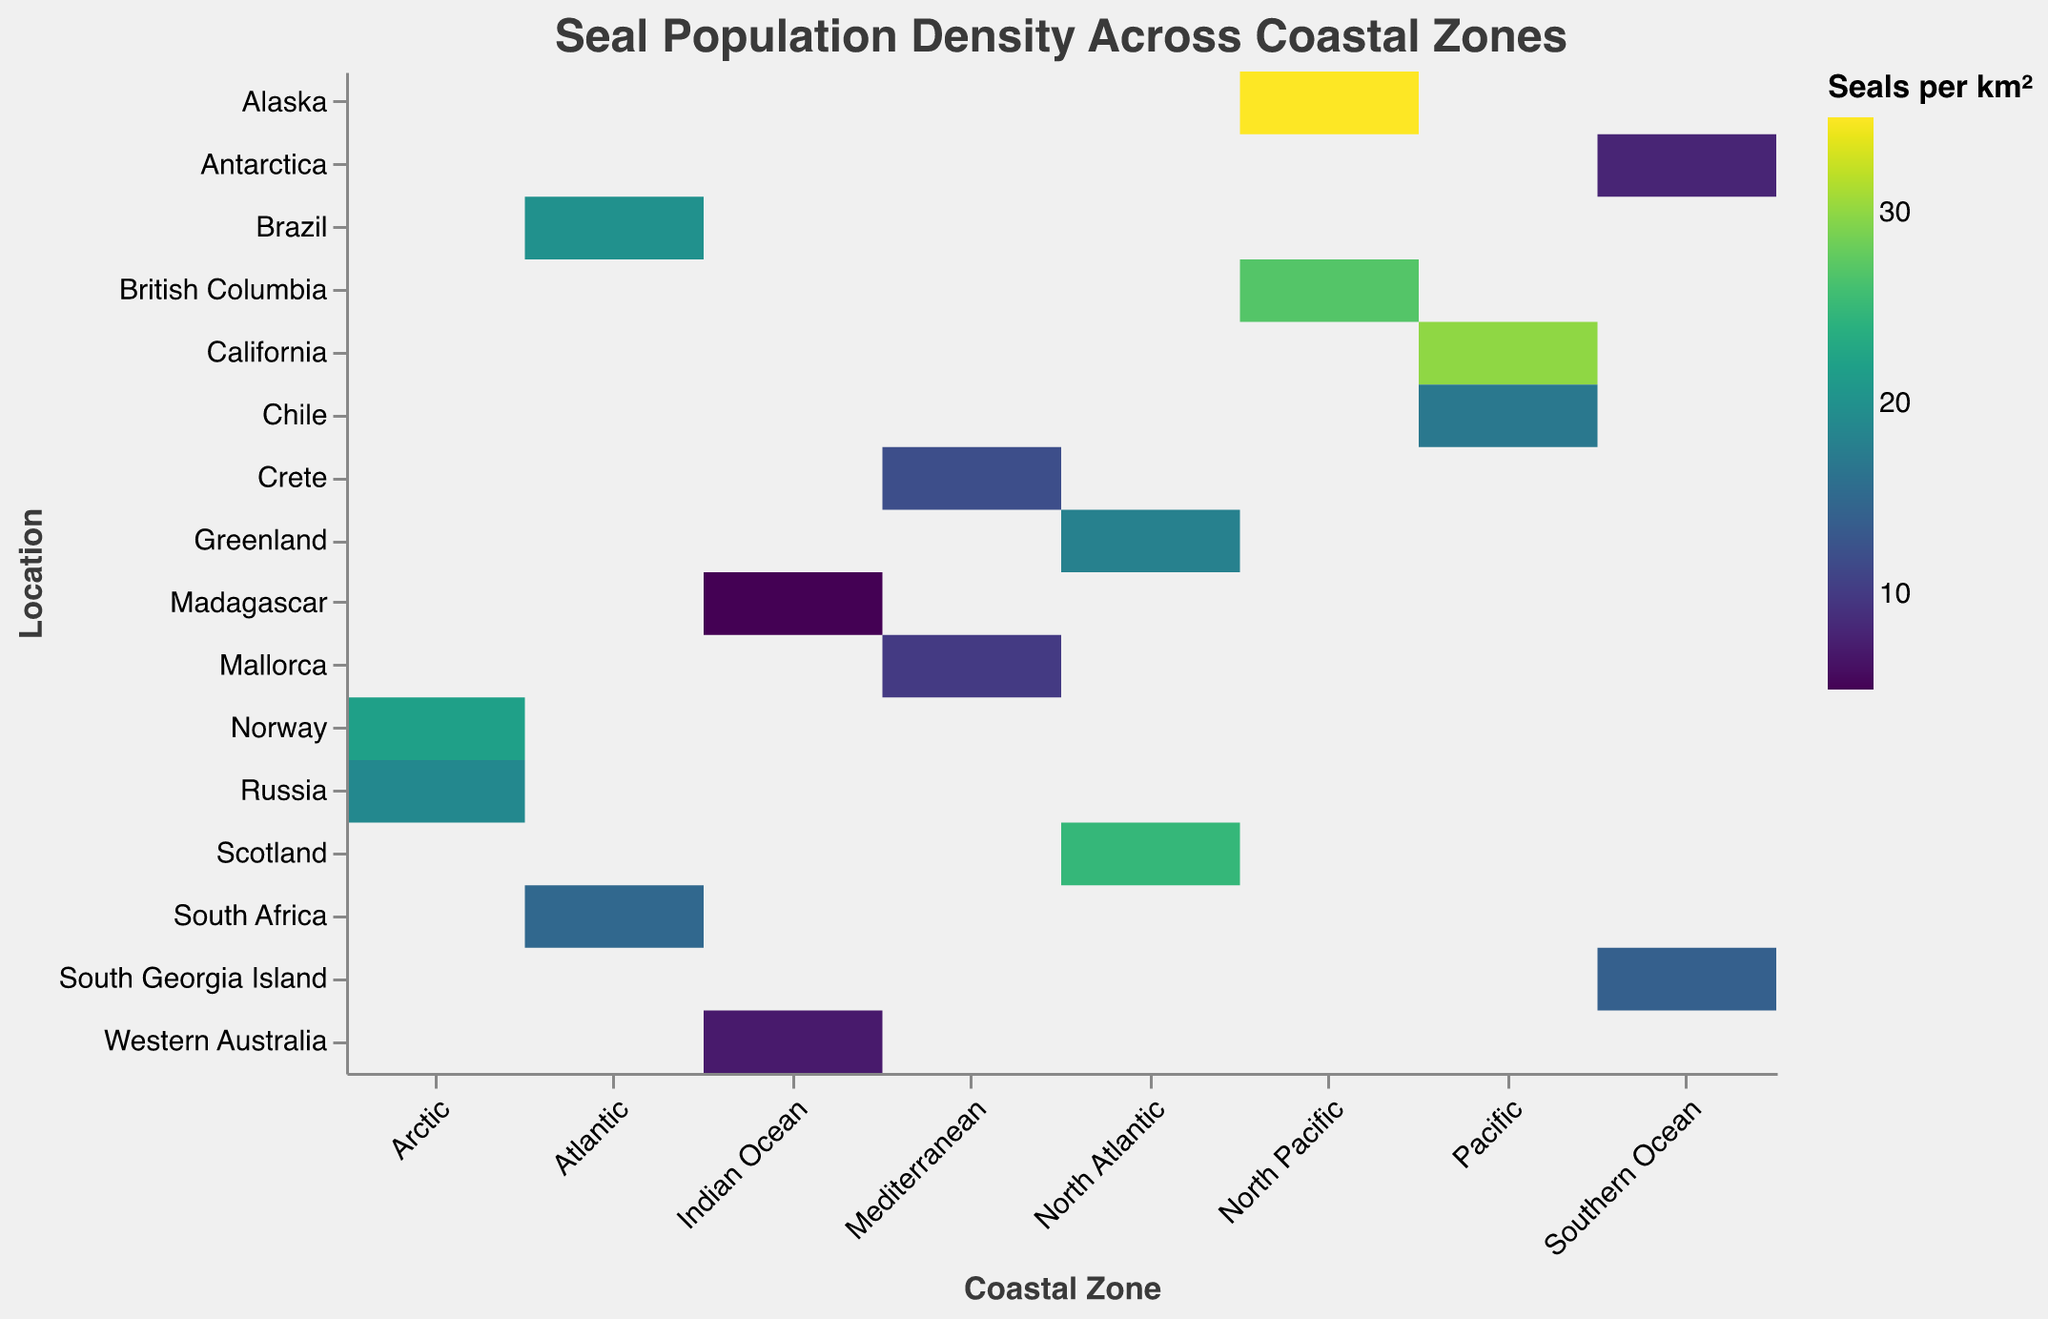Which coastal zone has the highest seal population density? Look at the heatmap and identify the coastal zone with the darkest color rectangle, which represents the highest population density. The darkest color is found in the North Pacific zone, particularly Alaska.
Answer: North Pacific What is the population density of seals in Madagascar? Find Madagascar on the y-axis and look at the color intensity of the corresponding rectangle. It is relatively light compared to others, which means a lower population density. The tooltip indicates the exact value.
Answer: 5 seals per square km How does the population density in Alaska compare with that in British Columbia? Compare the color intensities of the rectangles corresponding to Alaska and British Columbia in the North Pacific zone. Alaska has a darker color than British Columbia, indicating a higher population density. Specifically, Alaska has 35 seals per square km while British Columbia has 27.
Answer: Alaska has a higher population density Which location in the Atlantic zone has a higher seal population density: Brazil or South Africa? Compare the color intensities of the rectangles for Brazil and South Africa in the Atlantic zone. The rectangle for Brazil is darker, which indicates a higher population density.
Answer: Brazil What is the average seal population density in the Southern Ocean zone? Locate the Southern Ocean zone on the x-axis and focus on the two rectangles for Antarctica and South Georgia Island. The population densities are 8 and 14 seals per square km, respectively. Calculate the average: (8 + 14) / 2 = 11.
Answer: 11 seals per square km Which coastal zone has the lowest seal population density and what is the corresponding location? Identify the rectangle with the lightest color on the heatmap, which signifies the lowest population density. This is found in the Indian Ocean zone with the Madagascar location.
Answer: Indian Ocean, Madagascar Compare the seal population density between Scotland (North Atlantic) and Norway (Arctic). Locate the rectangles for Scotland and Norway on the heatmap and compare their color intensities. Scotland has a darker color compared to Norway, indicating a higher population density. Scotland has 25 seals per square km while Norway has 22.
Answer: Scotland has a higher population density What is the total seal population density for all locations in the North Atlantic zone? Identify the population densities for Scotland and Greenland (25 and 18 seals per square km respectively) and sum them up: 25 + 18 = 43.
Answer: 43 seals per square km Which is the location with the median seal population density across all zones? List all population densities (25, 18, 35, 27, 8, 14, 10, 12, 22, 19, 5, 7, 20, 15, 30, 17) in ascending order (5, 7, 8, 10, 12, 14, 15, 17, 18, 19, 20, 22, 25, 27, 30, 35). The median is the average of the 8th and 9th values (17 and 18), so the median is 17.5, corresponding to either Chile or Greenland.
Answer: Chile or Greenland What is the difference in seal population density between California (Pacific zone) and Chile (Pacific zone)? Locate the population densities for California and Chile. California has 30 seals per square km, and Chile has 17. Subtract the two values: 30 - 17 = 13.
Answer: 13 seals per square km 